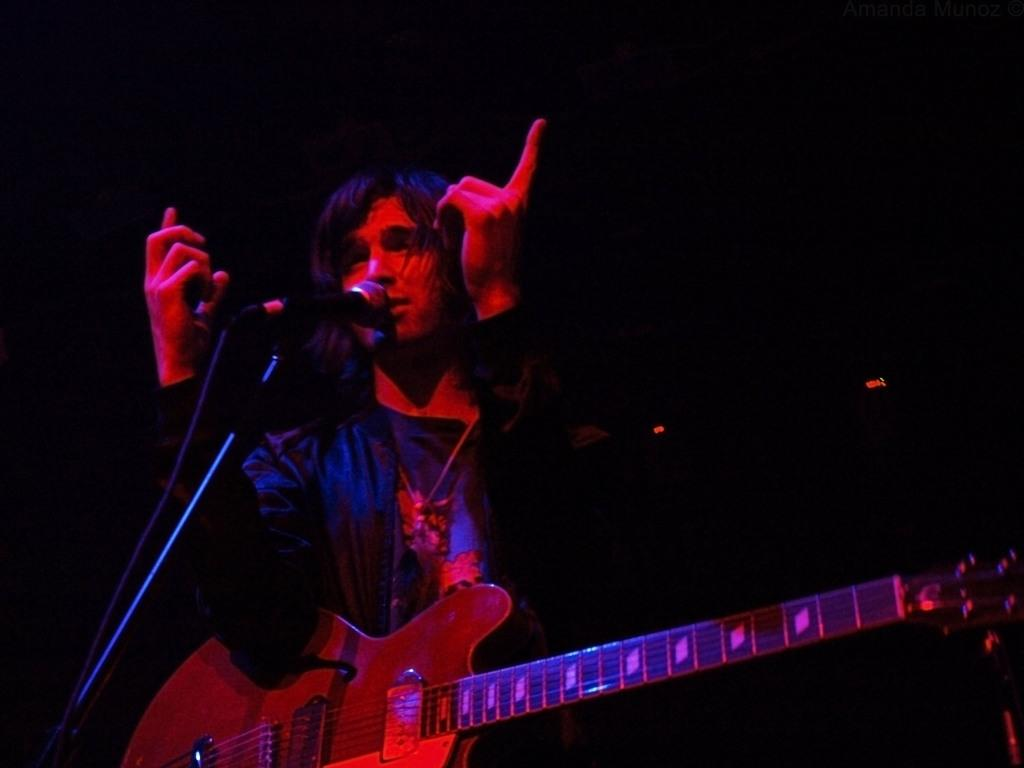What is the main subject of the image? The main subject of the image is a man. What is the man doing in the image? The man is standing and singing a song. What instrument is the man holding in the image? The man is holding a guitar. What device is present for amplifying the man's voice? There is a microphone in the image, which is attached to a mic stand. How would you describe the lighting in the image? The background of the image is dark. Can you see any slaves in the image? There are no slaves present in the image. Is the man shaking his head in the image? The provided facts do not mention the man shaking his head, so we cannot definitively answer that question. 